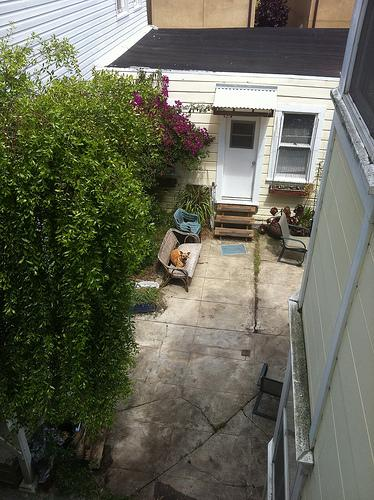Point out a peculiar detail about the patio's surface. The patio's surface shows evidence of wear, with a large crack in the concrete identified as a distinctive feature. Write a referential expression grounding task question based on the image, and provide an appropriate answer. The white door is located beneath the white awning, serving as an entrance to the house featured in the image. For a product advertisement task, mention a suitable product related to the image and write an advertising tagline. Tagline: "Upgrade your outdoor living space with our stylish and comfortable patio furniture set - perfect for relaxing and enjoying nature's beauty!" Choose a color of an object in the image and explain which object it is. Blue color can be seen on the stack of plastic chairs, the sky blue armchair, and the blue door mat on the ground. Describe the vegetation in the picture. In the image, there's a plant growing beside the house, purple flowers by the door, a thick green tree in the background, and a row of weeds on the ground. Tell me about the house's exterior in this image. The house has a black roof, a white wooden wall, a white door, a window next to the door, a flower box on the window, a white awning over the door, and wooden steps leading up to the door. Mention the types of chairs that can be seen in the image. There are several types of chairs, including a stack of blue plastic chairs, a brown chair, a sky blue armchair, an empty armchair, an outdoor patio chair, and a blue patio chair. Explain the scene and surroundings of a bench in the image. A gray bench is situated in the patio area, with a dog lying on it. There are chairs nearby and a cracked concrete ground beneath it. Where can the dog be located in the image? The dog can be found lying on a gray bench in the patio area, surrounded by chairs and other outdoor furniture. What is the focus of the image? Provide a brief explanation. The focus of the image is an outdoor scene featuring a house with a patio and various objects, like chairs, a bench, plants, and a dog lying on the bench. 